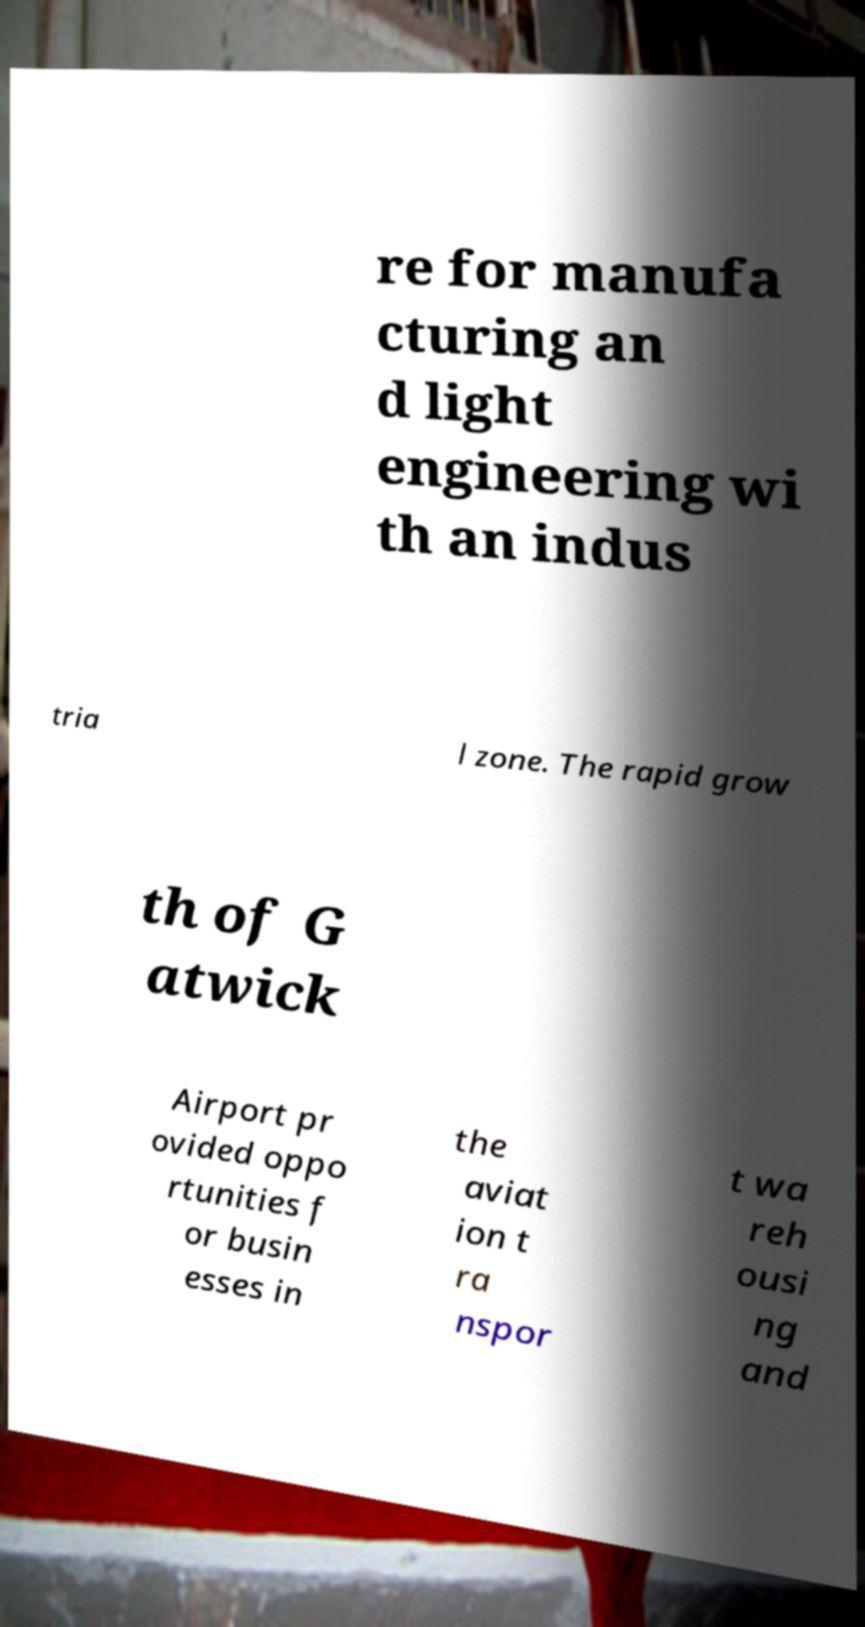Could you extract and type out the text from this image? re for manufa cturing an d light engineering wi th an indus tria l zone. The rapid grow th of G atwick Airport pr ovided oppo rtunities f or busin esses in the aviat ion t ra nspor t wa reh ousi ng and 